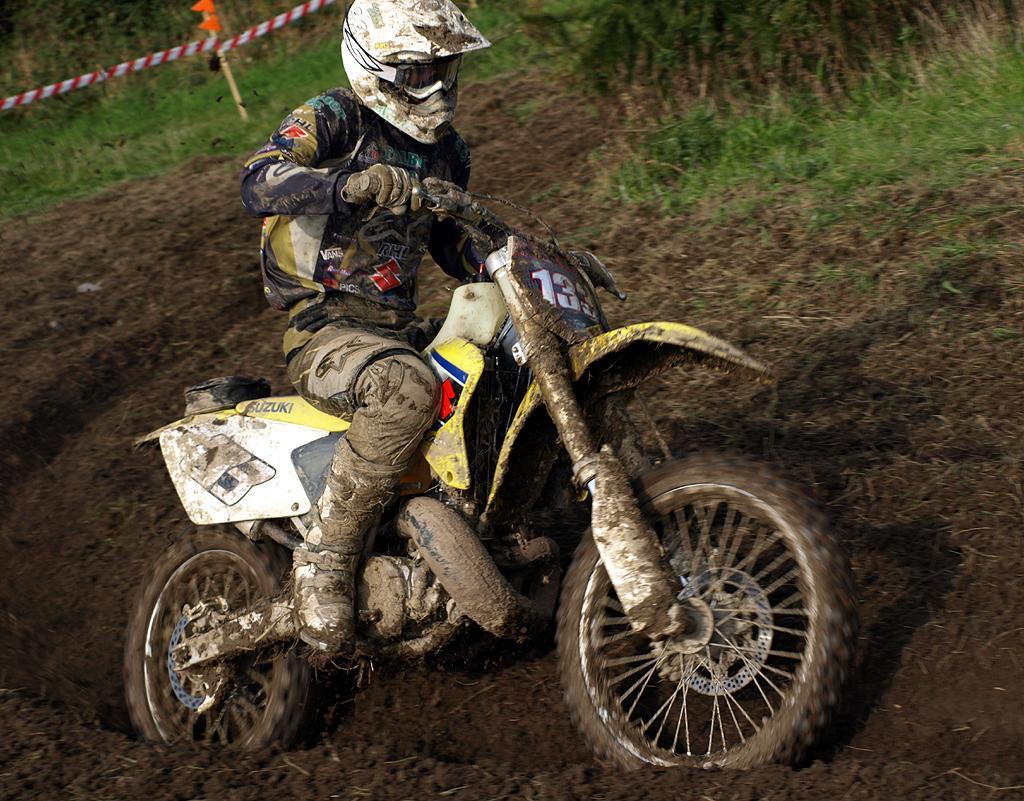How would you summarize this image in a sentence or two? In this image I can see a person sitting on the bike. In the background, I can see the grass. 